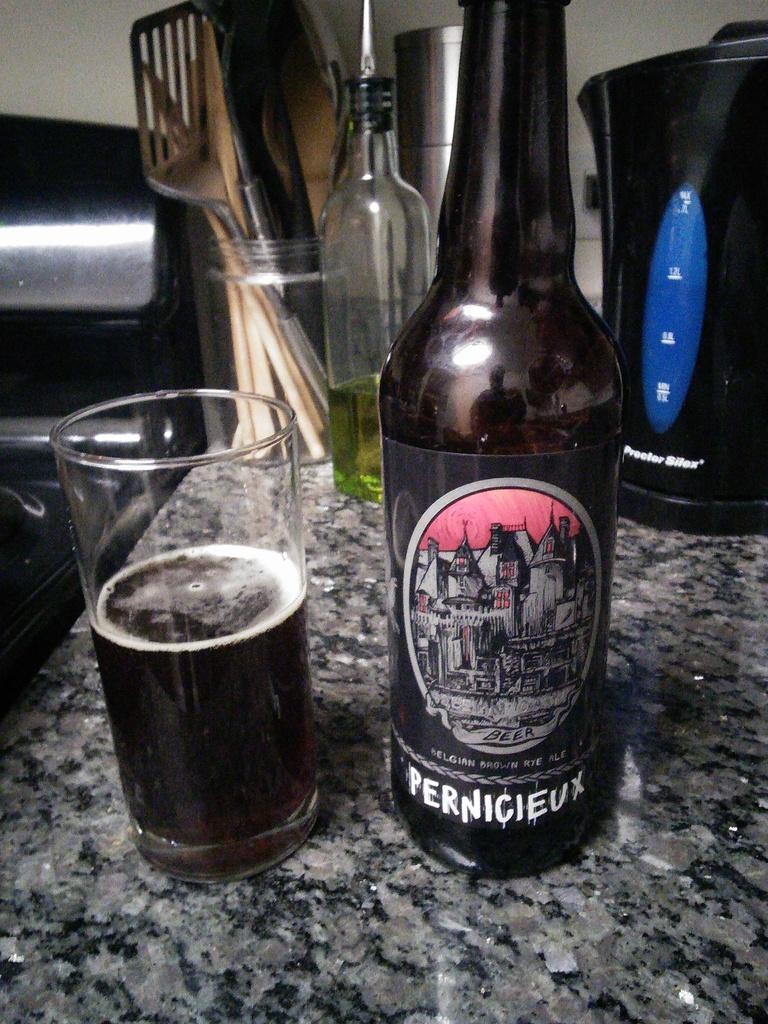Who makes this brand of beer?
Give a very brief answer. Pernicieux. 